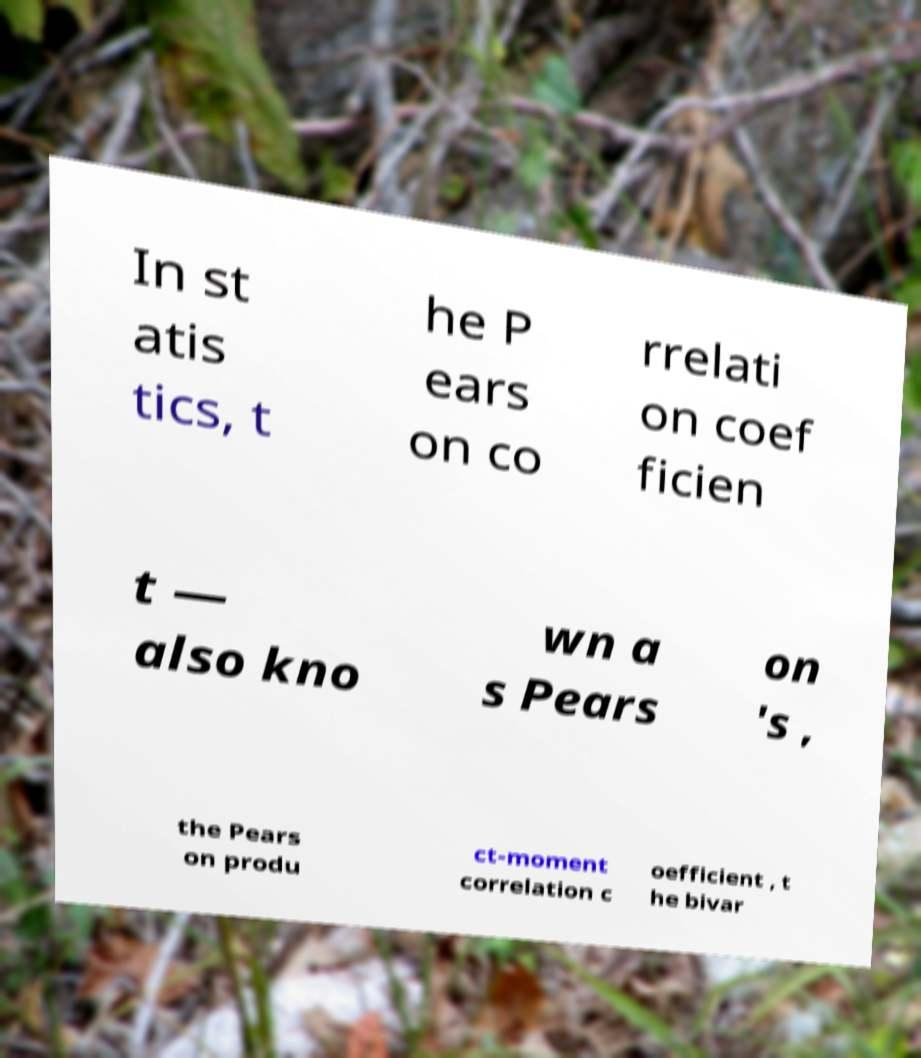Please identify and transcribe the text found in this image. In st atis tics, t he P ears on co rrelati on coef ficien t ― also kno wn a s Pears on 's , the Pears on produ ct-moment correlation c oefficient , t he bivar 